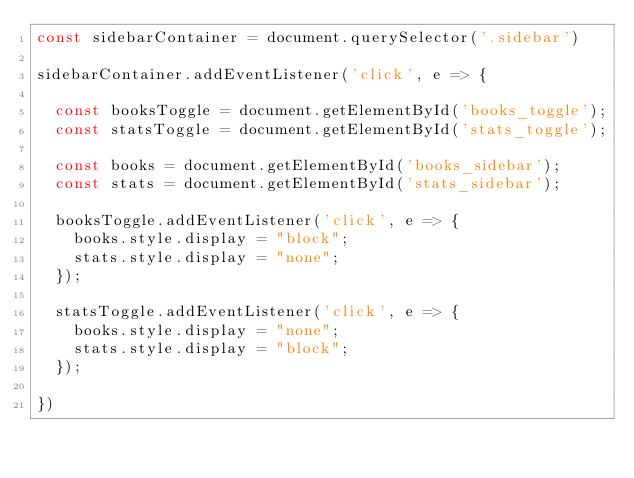<code> <loc_0><loc_0><loc_500><loc_500><_JavaScript_>const sidebarContainer = document.querySelector('.sidebar')

sidebarContainer.addEventListener('click', e => {

  const booksToggle = document.getElementById('books_toggle');
  const statsToggle = document.getElementById('stats_toggle');

  const books = document.getElementById('books_sidebar');
  const stats = document.getElementById('stats_sidebar');

  booksToggle.addEventListener('click', e => {
    books.style.display = "block";
    stats.style.display = "none";
  });

  statsToggle.addEventListener('click', e => {
    books.style.display = "none";
    stats.style.display = "block";
  });

})
</code> 